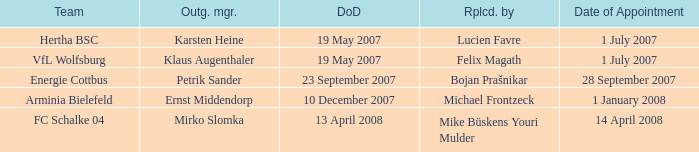When was the departure date when a manager was replaced by Bojan Prašnikar? 23 September 2007. 